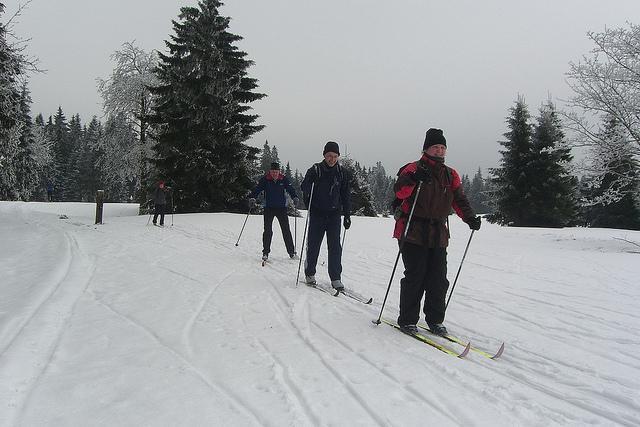How many ski poles are stuck into the snow?
Give a very brief answer. 8. How many skis are there?
Give a very brief answer. 8. How many people are there?
Give a very brief answer. 3. 